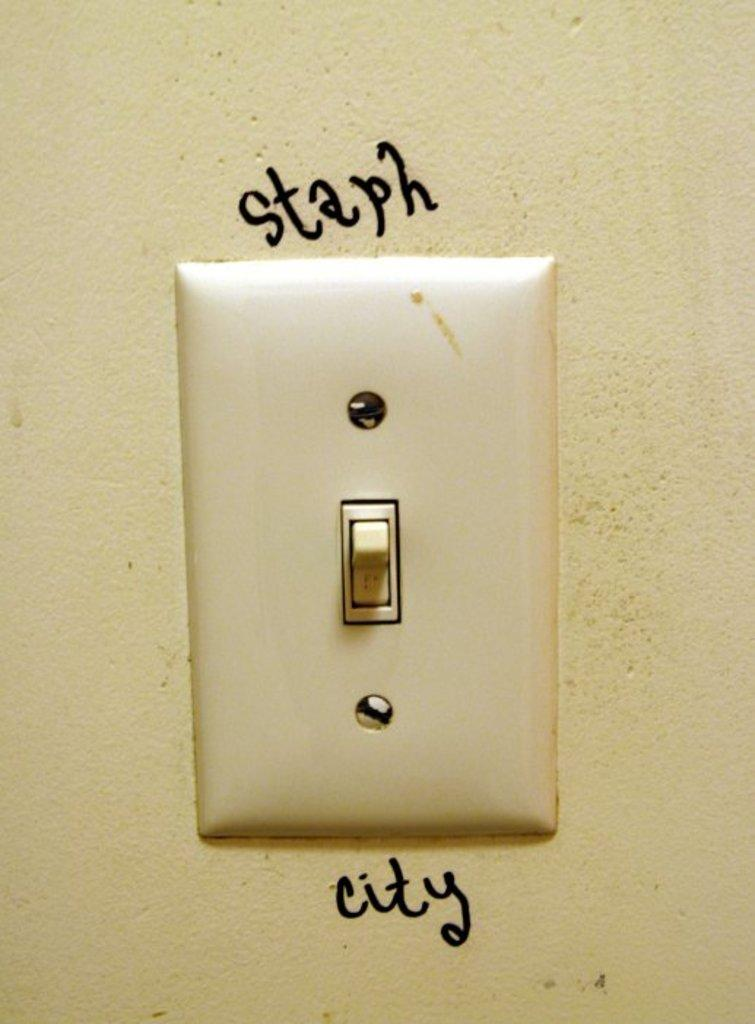<image>
Describe the image concisely. A light switch has the word staph written directly above it. 